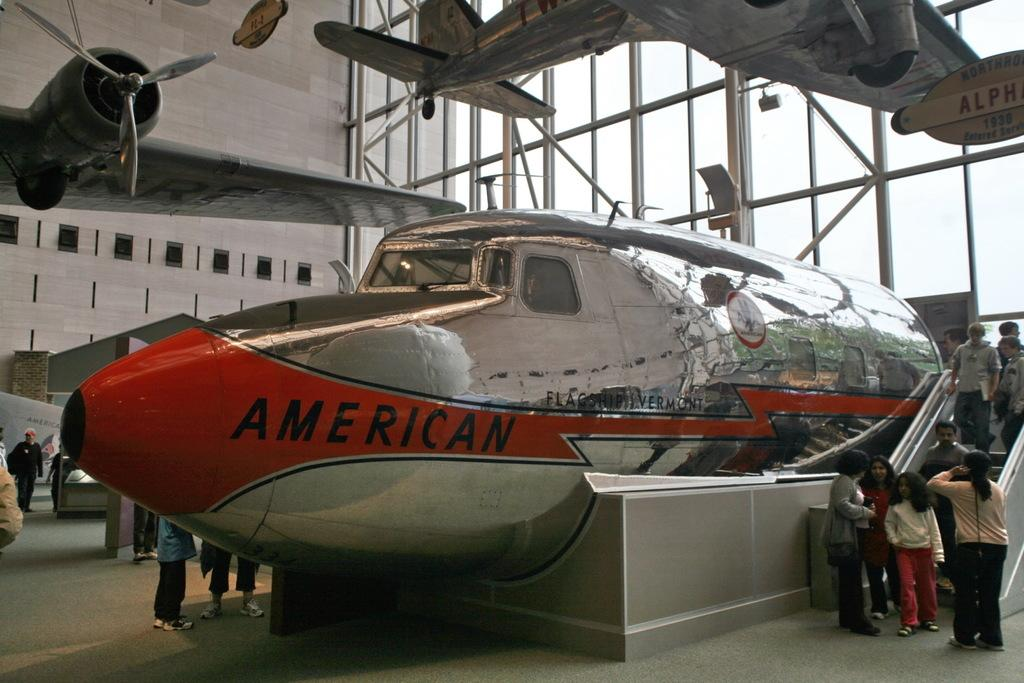<image>
Present a compact description of the photo's key features. The front part of a plane fuselage that reads AMERICAN. 